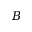Convert formula to latex. <formula><loc_0><loc_0><loc_500><loc_500>B</formula> 